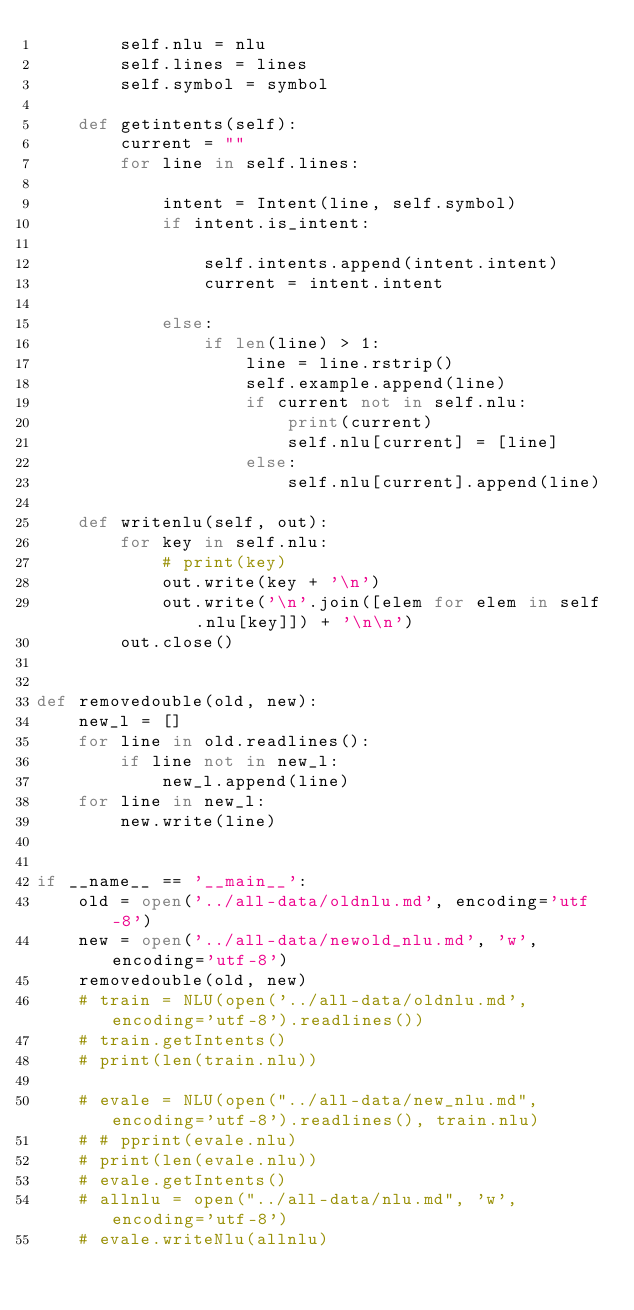Convert code to text. <code><loc_0><loc_0><loc_500><loc_500><_Python_>        self.nlu = nlu
        self.lines = lines
        self.symbol = symbol

    def getintents(self):
        current = ""
        for line in self.lines:

            intent = Intent(line, self.symbol)
            if intent.is_intent:

                self.intents.append(intent.intent)
                current = intent.intent

            else:
                if len(line) > 1:
                    line = line.rstrip()
                    self.example.append(line)
                    if current not in self.nlu:
                        print(current)
                        self.nlu[current] = [line]
                    else:
                        self.nlu[current].append(line)

    def writenlu(self, out):
        for key in self.nlu:
            # print(key)
            out.write(key + '\n')
            out.write('\n'.join([elem for elem in self.nlu[key]]) + '\n\n')
        out.close()


def removedouble(old, new):
    new_l = []
    for line in old.readlines():
        if line not in new_l:
            new_l.append(line)
    for line in new_l:
        new.write(line)


if __name__ == '__main__':
    old = open('../all-data/oldnlu.md', encoding='utf-8')
    new = open('../all-data/newold_nlu.md', 'w', encoding='utf-8')
    removedouble(old, new)
    # train = NLU(open('../all-data/oldnlu.md', encoding='utf-8').readlines())
    # train.getIntents()
    # print(len(train.nlu))

    # evale = NLU(open("../all-data/new_nlu.md", encoding='utf-8').readlines(), train.nlu)
    # # pprint(evale.nlu)
    # print(len(evale.nlu))
    # evale.getIntents()
    # allnlu = open("../all-data/nlu.md", 'w', encoding='utf-8')
    # evale.writeNlu(allnlu)
</code> 